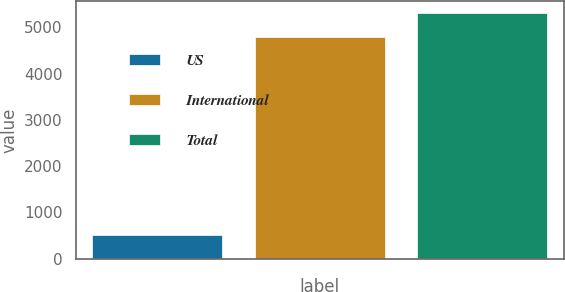<chart> <loc_0><loc_0><loc_500><loc_500><bar_chart><fcel>US<fcel>International<fcel>Total<nl><fcel>513<fcel>4790<fcel>5303<nl></chart> 